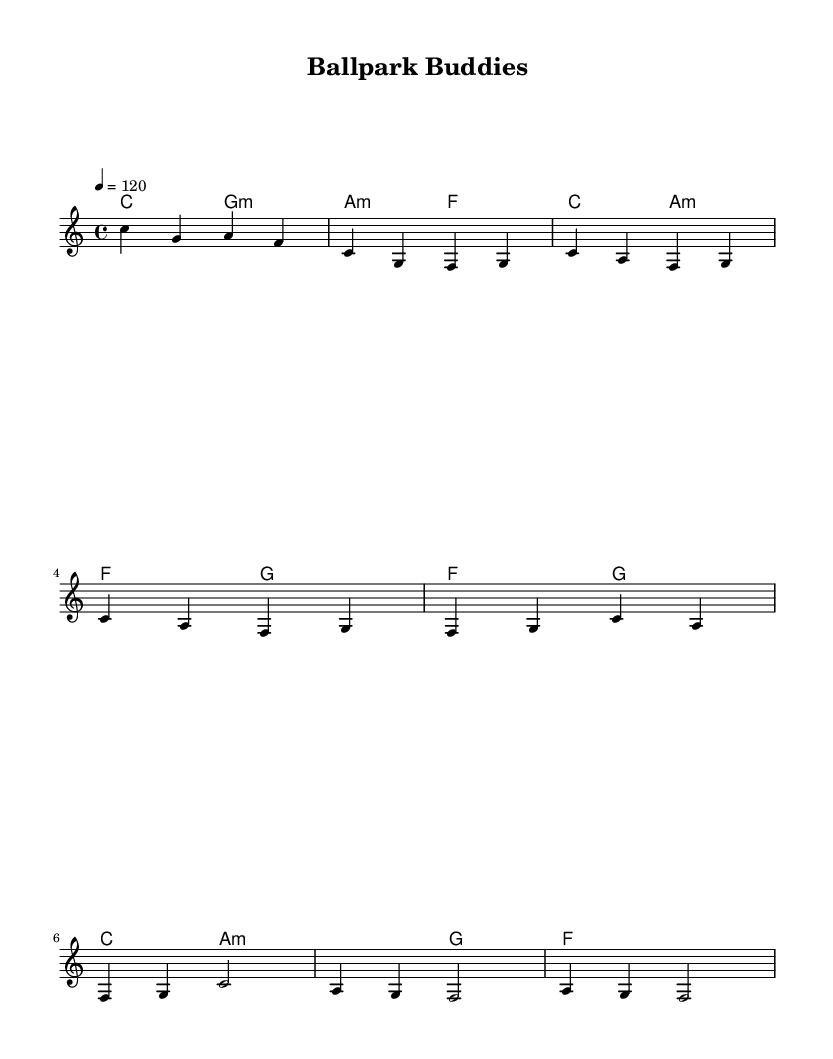what is the key signature of this music? The key signature shown in the sheet music is C major, which is indicated by the absence of any sharps or flats.
Answer: C major what is the time signature of this music? The time signature, which is shown at the beginning of the score, is 4/4, meaning there are four beats per measure and the quarter note gets one beat.
Answer: 4/4 what is the tempo marking of this music? The tempo is indicated in the score as "4 = 120," which means there are 120 beats per minute, and each beat corresponds to a quarter note.
Answer: 120 how many measures are in the chorus section? By analyzing the structure of the score, the chorus is composed of 2 measures as shown in the written section.
Answer: 2 what chord is played during the first measure of the bridge? The first measure of the bridge uses the chord a minor, which is indicated in the harmonies section.
Answer: a minor which section has the lyrics about friendship and camaraderie? The sheet music represents a structure, but the title "Ballpark Buddies" suggests the entire piece revolves around themes of friendship and camaraderie, as inferred from the title rather than specific lyrics shown in the music itself.
Answer: Ballpark Buddies 